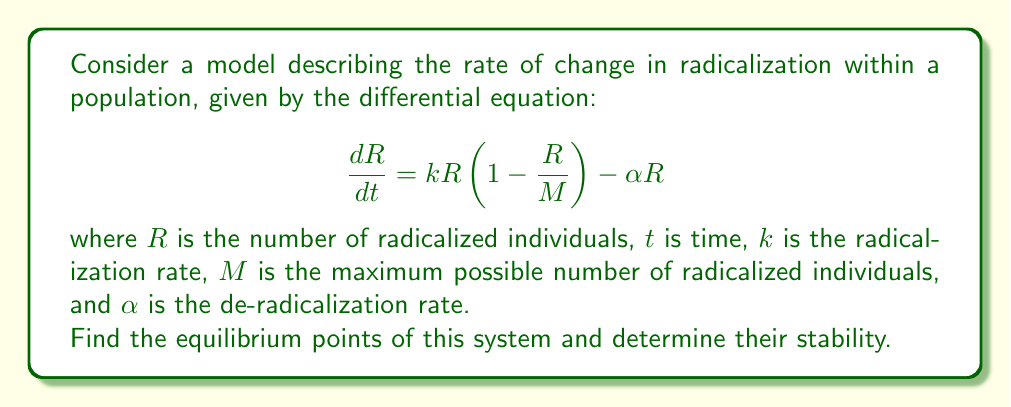Show me your answer to this math problem. To solve this problem, we'll follow these steps:

1) Find the equilibrium points by setting $\frac{dR}{dt} = 0$
2) Analyze the stability of each equilibrium point

Step 1: Finding equilibrium points

Set $\frac{dR}{dt} = 0$:

$$kR(1-\frac{R}{M}) - \alpha R = 0$$

Factor out $R$:

$$R(k(1-\frac{R}{M}) - \alpha) = 0$$

This equation is satisfied when either $R = 0$ or $k(1-\frac{R}{M}) - \alpha = 0$

For the second case:

$$k - \frac{kR}{M} - \alpha = 0$$
$$\frac{kR}{M} = k - \alpha$$
$$R = M(1 - \frac{\alpha}{k})$$

Therefore, the equilibrium points are:
$R_1 = 0$ and $R_2 = M(1 - \frac{\alpha}{k})$

Step 2: Analyzing stability

To determine stability, we need to find $\frac{d}{dR}(\frac{dR}{dt})$ at each equilibrium point:

$$\frac{d}{dR}(\frac{dR}{dt}) = k(1-\frac{2R}{M}) - \alpha$$

At $R_1 = 0$:
$$\frac{d}{dR}(\frac{dR}{dt}) = k - \alpha$$

If $k > \alpha$, this is positive, and $R_1 = 0$ is unstable.
If $k < \alpha$, this is negative, and $R_1 = 0$ is stable.

At $R_2 = M(1 - \frac{\alpha}{k})$:
$$\frac{d}{dR}(\frac{dR}{dt}) = k(1-\frac{2M(1 - \frac{\alpha}{k})}{M}) - \alpha$$
$$= k(1-2+\frac{2\alpha}{k}) - \alpha$$
$$= -k+2\alpha - \alpha = \alpha - k$$

If $k > \alpha$, this is negative, and $R_2$ is stable.
If $k < \alpha$, $R_2$ is negative and thus not biologically meaningful.
Answer: The equilibrium points are $R_1 = 0$ and $R_2 = M(1 - \frac{\alpha}{k})$.

When $k > \alpha$:
$R_1 = 0$ is unstable
$R_2 = M(1 - \frac{\alpha}{k})$ is stable

When $k < \alpha$:
$R_1 = 0$ is stable
$R_2$ is not biologically meaningful 